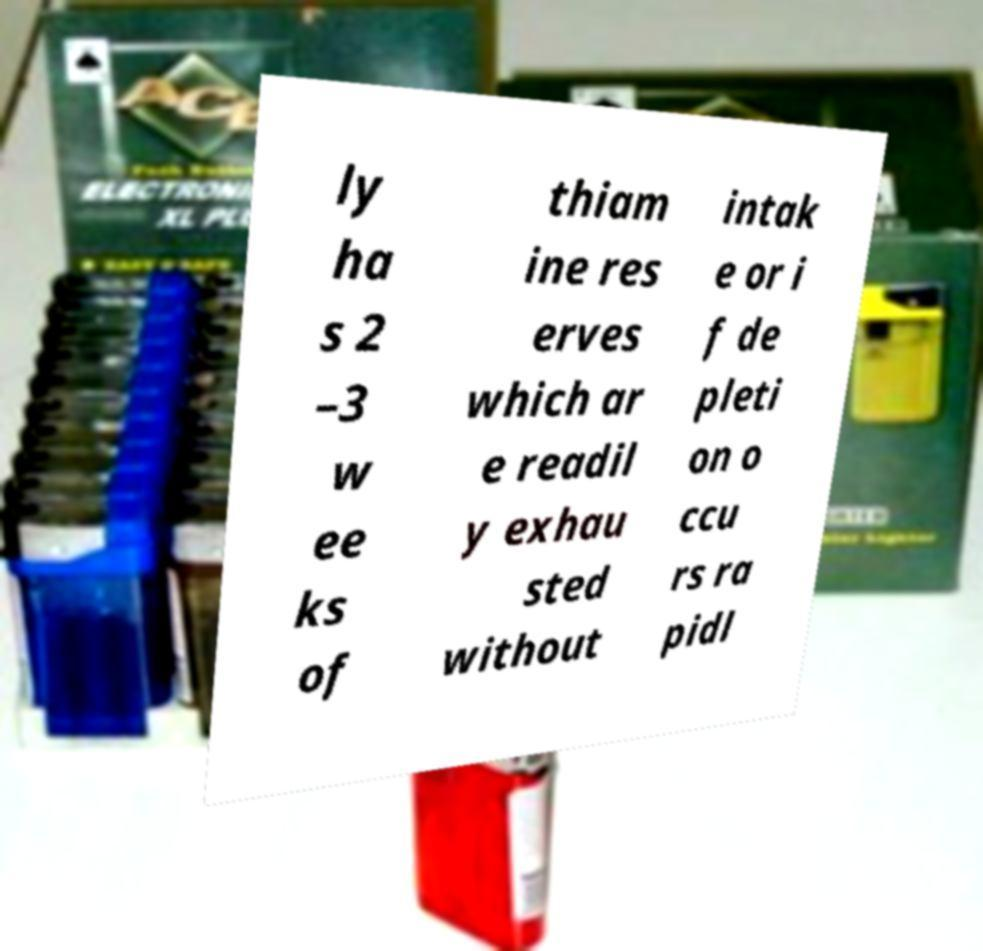Can you read and provide the text displayed in the image?This photo seems to have some interesting text. Can you extract and type it out for me? ly ha s 2 –3 w ee ks of thiam ine res erves which ar e readil y exhau sted without intak e or i f de pleti on o ccu rs ra pidl 